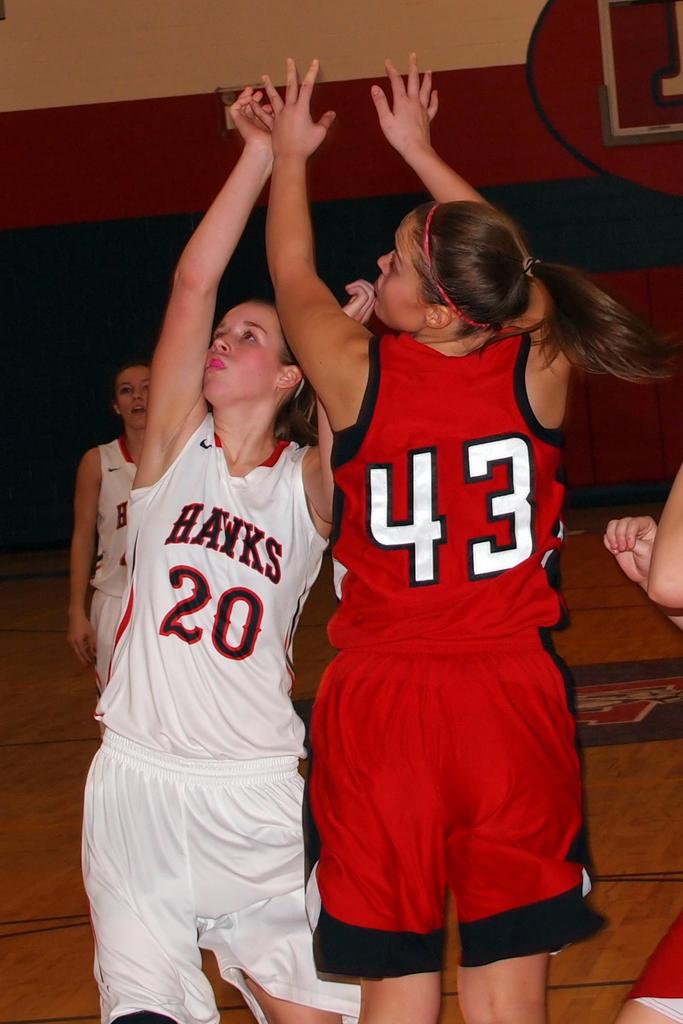Provide a one-sentence caption for the provided image. Two women playing in a game of basketball. 